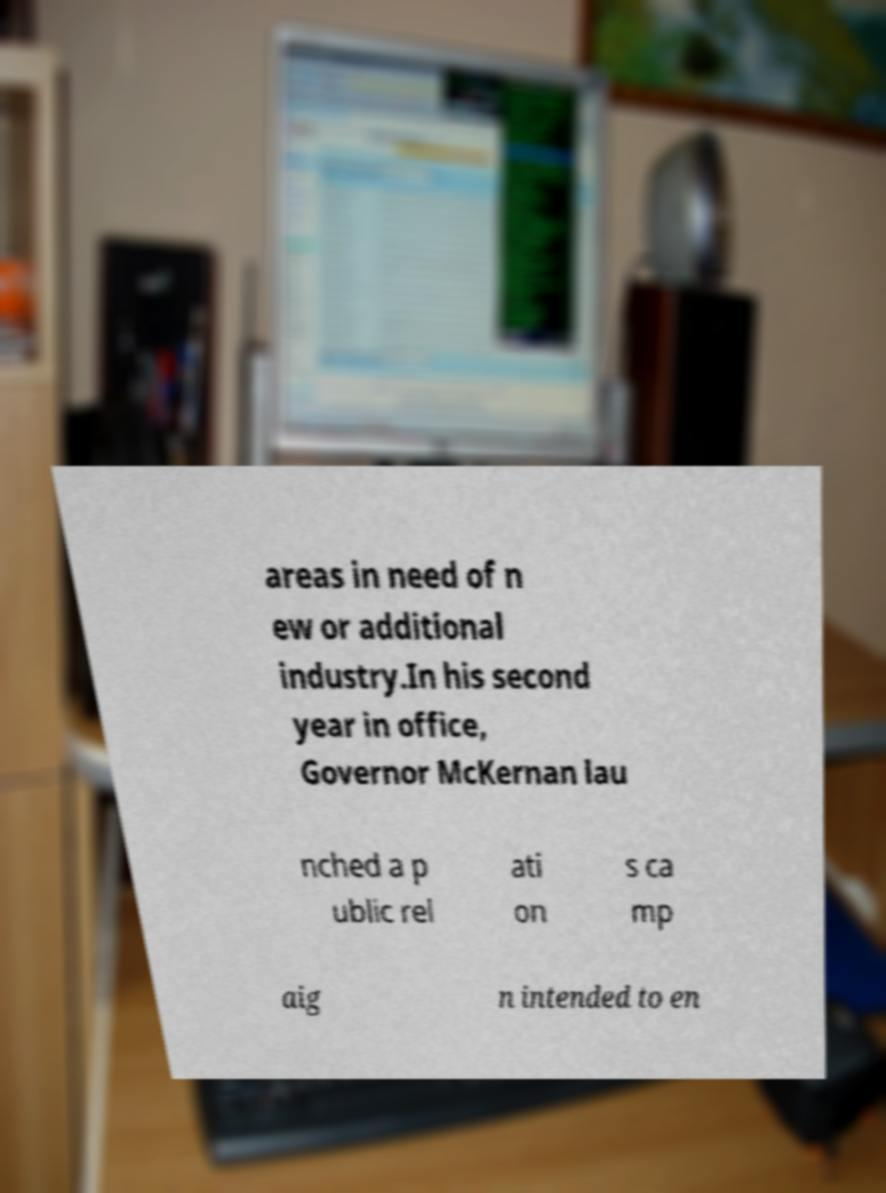For documentation purposes, I need the text within this image transcribed. Could you provide that? areas in need of n ew or additional industry.In his second year in office, Governor McKernan lau nched a p ublic rel ati on s ca mp aig n intended to en 